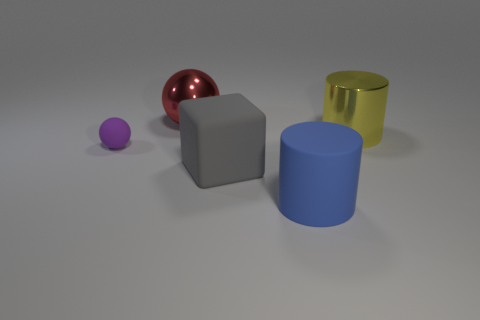There is a big matte thing behind the large blue matte cylinder; what shape is it?
Provide a succinct answer. Cube. Is the size of the purple sphere the same as the shiny thing that is behind the yellow metallic cylinder?
Offer a very short reply. No. Is there a tiny green block made of the same material as the red sphere?
Provide a short and direct response. No. How many balls are either big shiny objects or small objects?
Your response must be concise. 2. Are there any purple things right of the ball that is in front of the red sphere?
Your answer should be very brief. No. Are there fewer tiny objects than balls?
Your answer should be very brief. Yes. How many other red objects have the same shape as the small matte thing?
Offer a very short reply. 1. What number of purple things are either rubber balls or metal cylinders?
Your answer should be very brief. 1. There is a ball that is in front of the cylinder behind the purple matte ball; what size is it?
Give a very brief answer. Small. There is another thing that is the same shape as the big yellow object; what is it made of?
Make the answer very short. Rubber. 